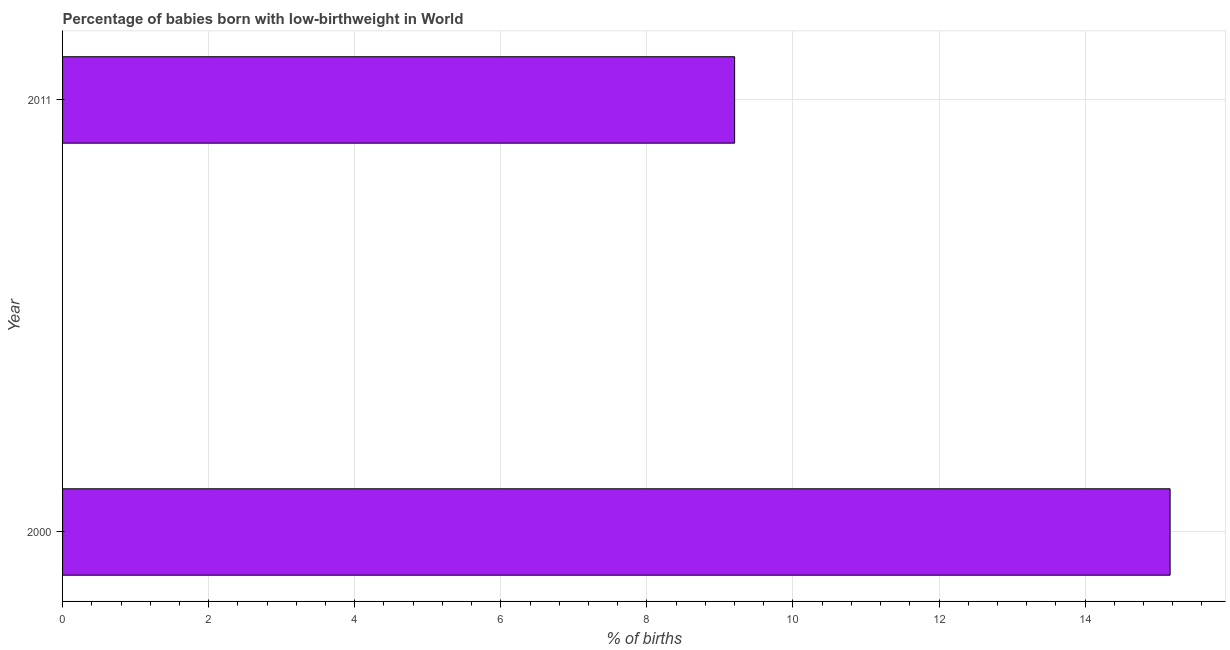Does the graph contain any zero values?
Offer a very short reply. No. Does the graph contain grids?
Your answer should be very brief. Yes. What is the title of the graph?
Make the answer very short. Percentage of babies born with low-birthweight in World. What is the label or title of the X-axis?
Offer a terse response. % of births. What is the label or title of the Y-axis?
Keep it short and to the point. Year. What is the percentage of babies who were born with low-birthweight in 2000?
Make the answer very short. 15.16. Across all years, what is the maximum percentage of babies who were born with low-birthweight?
Give a very brief answer. 15.16. Across all years, what is the minimum percentage of babies who were born with low-birthweight?
Your answer should be very brief. 9.2. What is the sum of the percentage of babies who were born with low-birthweight?
Your answer should be compact. 24.37. What is the difference between the percentage of babies who were born with low-birthweight in 2000 and 2011?
Make the answer very short. 5.96. What is the average percentage of babies who were born with low-birthweight per year?
Make the answer very short. 12.18. What is the median percentage of babies who were born with low-birthweight?
Your response must be concise. 12.18. In how many years, is the percentage of babies who were born with low-birthweight greater than 4 %?
Provide a short and direct response. 2. Do a majority of the years between 2000 and 2011 (inclusive) have percentage of babies who were born with low-birthweight greater than 8 %?
Give a very brief answer. Yes. What is the ratio of the percentage of babies who were born with low-birthweight in 2000 to that in 2011?
Your answer should be compact. 1.65. In how many years, is the percentage of babies who were born with low-birthweight greater than the average percentage of babies who were born with low-birthweight taken over all years?
Offer a very short reply. 1. How many years are there in the graph?
Give a very brief answer. 2. What is the difference between two consecutive major ticks on the X-axis?
Your answer should be compact. 2. Are the values on the major ticks of X-axis written in scientific E-notation?
Ensure brevity in your answer.  No. What is the % of births of 2000?
Offer a very short reply. 15.16. What is the % of births of 2011?
Provide a short and direct response. 9.2. What is the difference between the % of births in 2000 and 2011?
Offer a terse response. 5.96. What is the ratio of the % of births in 2000 to that in 2011?
Offer a terse response. 1.65. 